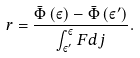<formula> <loc_0><loc_0><loc_500><loc_500>r = \frac { \bar { \Phi } \left ( \varepsilon \right ) - \bar { \Phi } \left ( \varepsilon ^ { \prime } \right ) } { \int _ { \varepsilon ^ { \prime } } ^ { \varepsilon } F d j } .</formula> 